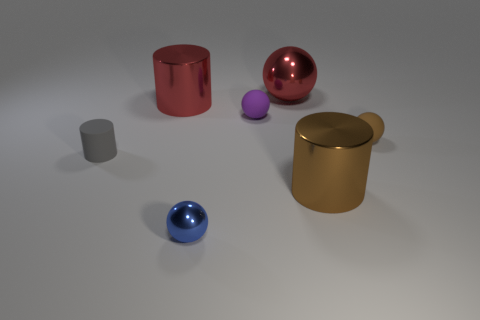What number of large red metal spheres are behind the rubber object to the left of the large thing that is on the left side of the red sphere? 1 